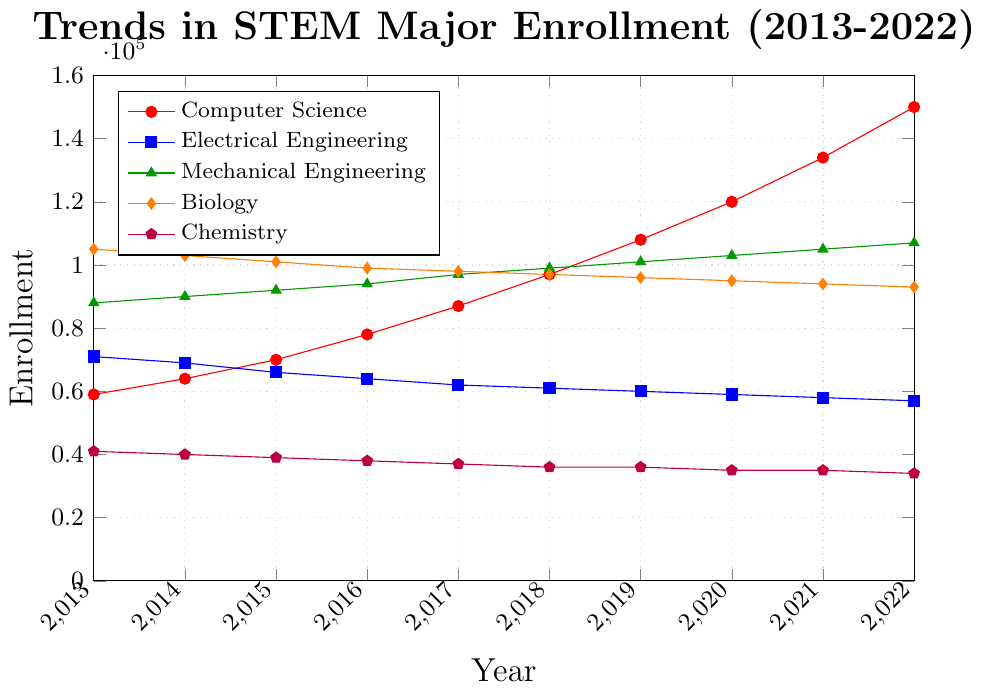What is the trend in enrollments for Computer Science from 2013 to 2022? Enrollment in Computer Science shows a consistent upward trend. Starting from 59,000 in 2013, it increases every year, reaching 150,000 in 2022.
Answer: Upward trend How does the enrollment in Mechanical Engineering in 2022 compare to Chemistry in 2022? In 2022, enrollment in Mechanical Engineering is 107,000, which is significantly higher than Chemistry's enrollment of 34,000.
Answer: Mechanical Engineering > Chemistry What is the average enrollment for Electrical Engineering from 2013 to 2022? Sum up the enrollments from 2013 to 2022: 71,000 + 69,000 + 66,000 + 64,000 + 62,000 + 61,000 + 60,000 + 59,000 + 58,000 + 57,000 = 627,000. Now divide this sum by the number of years (10): 627,000 / 10.
Answer: 62,700 Which major has the highest enrollment in 2013? In 2013, Biology has the highest enrollment with 105,000 students.
Answer: Biology What is the difference in enrollment between Computer Science and Biology in 2016? In 2016, Computer Science has 78,000 enrollments, and Biology has 99,000. The difference is 99,000 - 78,000.
Answer: 21,000 Which major shows a consistent decline in enrollment throughout the decade? Chemistry shows a consistent decline in enrollment every year from 2013 (41,000) to 2022 (34,000).
Answer: Chemistry What is the total increase in enrollment for Computer Science from 2013 to 2022? Subtract the 2013 enrollment from the 2022 enrollment for Computer Science: 150,000 - 59,000.
Answer: 91,000 How do the trends in Biology compare to Chemistry from 2013 to 2022? Both majors show a decreasing trend, but Biology has a more gradual decline (from 105,000 to 93,000) compared to Chemistry (from 41,000 to 34,000).
Answer: Both decline; Biology more gradual Which major had the least change in enrollment over the decade? Chemistry had the least change in enrollment, going from 41,000 in 2013 to 34,000 in 2022.
Answer: Chemistry What is the enrollment trend for Electrical Engineering from 2018 to 2022? From 2018 to 2022, enrollment in Electrical Engineering steadily decreases year by year, starting from 61,000 in 2018 to 57,000 in 2022.
Answer: Downward trend 